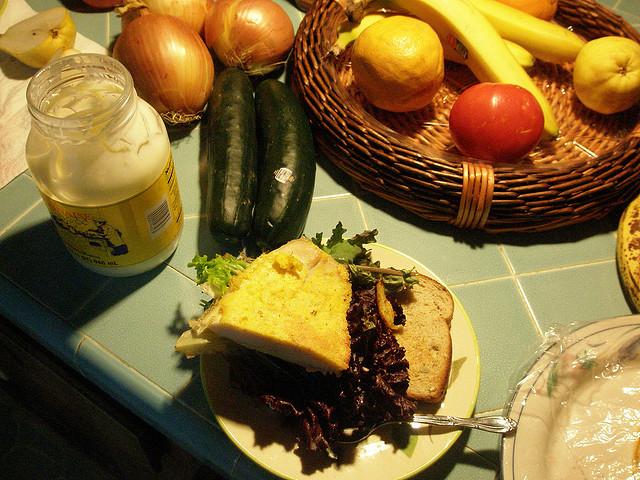How many different kinds of yellow fruit are in the bowl?
Write a very short answer. 2. Are the cucumbers touching?
Write a very short answer. Yes. What is in the open jar?
Concise answer only. Mayonnaise. 